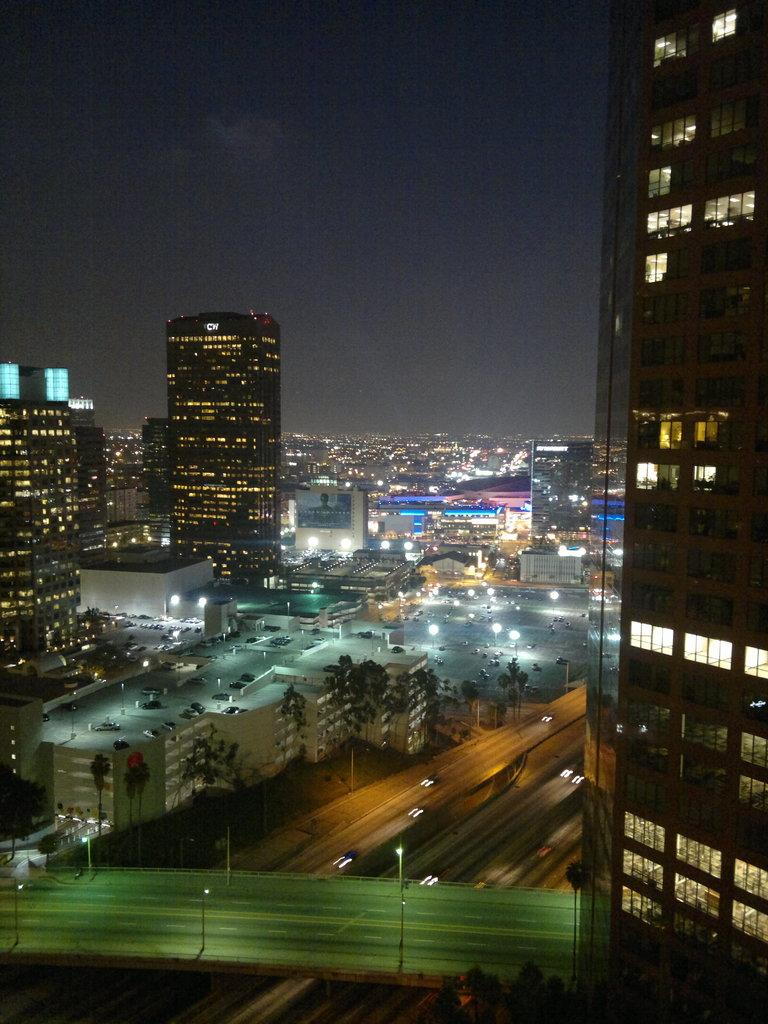What is the color of the sky in the background of the image? The sky is dark in the background of the image. What type of structures can be seen in the image? There are buildings in the image. What other natural elements are present in the image? Trees are present in the image. What man-made objects can be seen in the image? Vehicles are visible in the image. What type of lighting is present in the image? Lights are present in the image. What other objects can be seen in the image? Poles are visible in the image. What type of pathway is present in the image? There is a road in the image. What type of infrastructure is present in the image? There is a bridge in the image. What type of account does the bridge have in the image? The image does not depict an account; it shows a bridge as a physical structure. What type of thing is the mine in the image? There is no mine present in the image. 